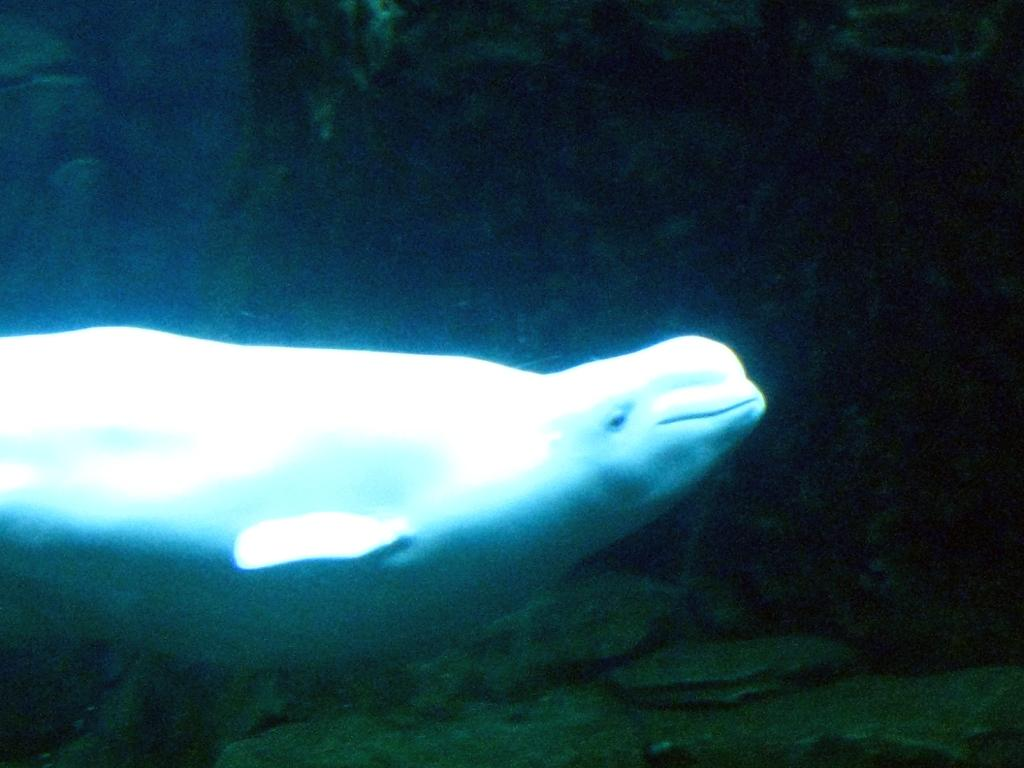What is the main subject in the center of the image? There is a dolphin in the center of the image. Can you describe the environment in which the dolphin is located? The dolphin is underwater. What type of clover can be seen growing on the roof in the image? There is no clover or roof present in the image; it features a dolphin underwater. What is the dolphin's interest in the image? The image does not depict the dolphin's interests or activities; it simply shows the dolphin underwater. 